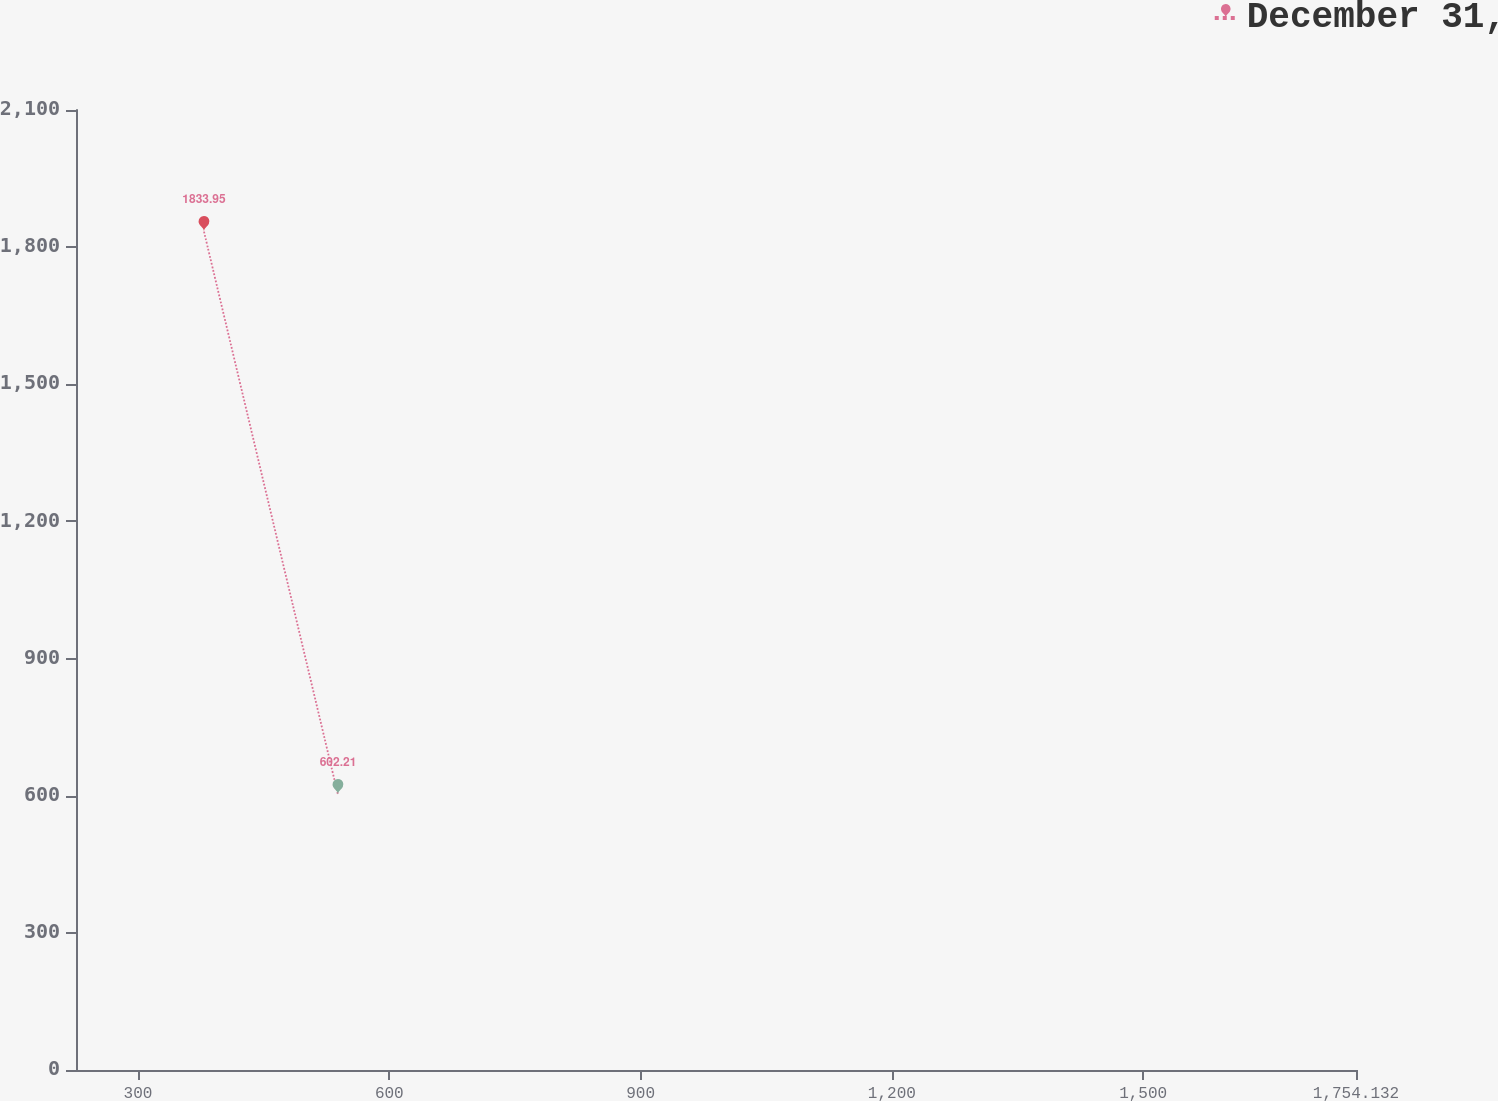Convert chart to OTSL. <chart><loc_0><loc_0><loc_500><loc_500><line_chart><ecel><fcel>December 31,<nl><fcel>378.77<fcel>1833.95<nl><fcel>538.72<fcel>602.21<nl><fcel>1906.95<fcel>348.81<nl></chart> 